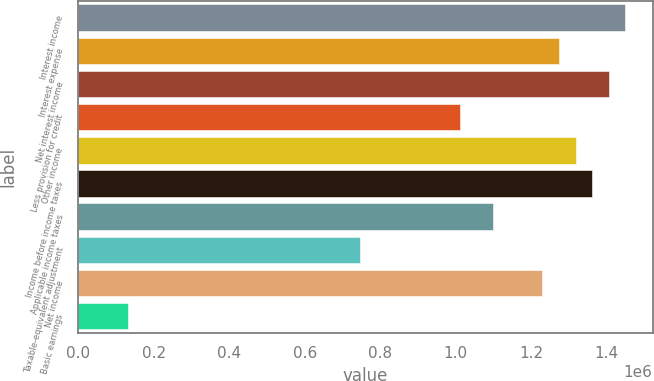<chart> <loc_0><loc_0><loc_500><loc_500><bar_chart><fcel>Interest income<fcel>Interest expense<fcel>Net interest income<fcel>Less provision for credit<fcel>Other income<fcel>Income before income taxes<fcel>Applicable income taxes<fcel>Taxable-equivalent adjustment<fcel>Net income<fcel>Basic earnings<nl><fcel>1.4493e+06<fcel>1.27363e+06<fcel>1.40538e+06<fcel>1.01012e+06<fcel>1.31755e+06<fcel>1.36146e+06<fcel>1.09795e+06<fcel>746609<fcel>1.22971e+06<fcel>131755<nl></chart> 